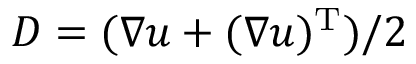<formula> <loc_0><loc_0><loc_500><loc_500>D = ( \nabla u + ( \nabla u ) ^ { T } ) / 2</formula> 